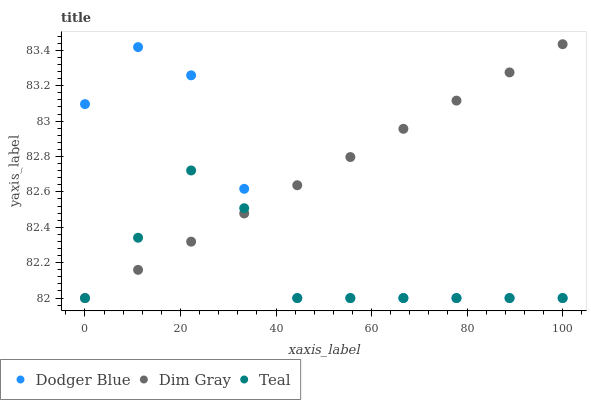Does Teal have the minimum area under the curve?
Answer yes or no. Yes. Does Dim Gray have the maximum area under the curve?
Answer yes or no. Yes. Does Dodger Blue have the minimum area under the curve?
Answer yes or no. No. Does Dodger Blue have the maximum area under the curve?
Answer yes or no. No. Is Dim Gray the smoothest?
Answer yes or no. Yes. Is Dodger Blue the roughest?
Answer yes or no. Yes. Is Teal the smoothest?
Answer yes or no. No. Is Teal the roughest?
Answer yes or no. No. Does Dim Gray have the lowest value?
Answer yes or no. Yes. Does Dim Gray have the highest value?
Answer yes or no. Yes. Does Dodger Blue have the highest value?
Answer yes or no. No. Does Dodger Blue intersect Teal?
Answer yes or no. Yes. Is Dodger Blue less than Teal?
Answer yes or no. No. Is Dodger Blue greater than Teal?
Answer yes or no. No. 